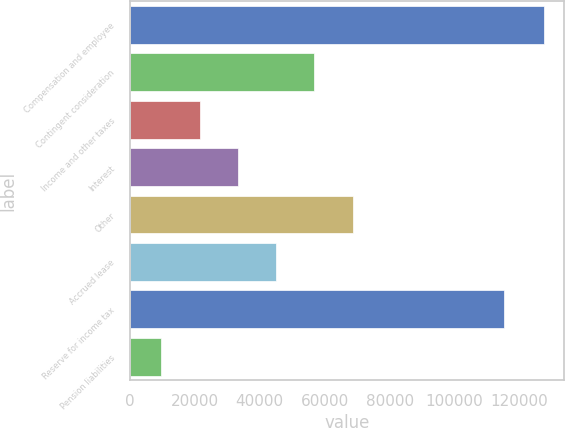Convert chart to OTSL. <chart><loc_0><loc_0><loc_500><loc_500><bar_chart><fcel>Compensation and employee<fcel>Contingent consideration<fcel>Income and other taxes<fcel>Interest<fcel>Other<fcel>Accrued lease<fcel>Reserve for income tax<fcel>Pension liabilities<nl><fcel>127464<fcel>56800.2<fcel>21468.3<fcel>33245.6<fcel>68577.5<fcel>45022.9<fcel>115395<fcel>9691<nl></chart> 